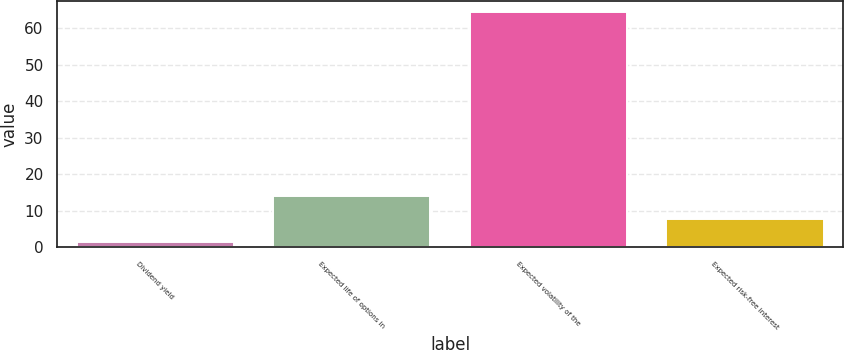<chart> <loc_0><loc_0><loc_500><loc_500><bar_chart><fcel>Dividend yield<fcel>Expected life of options in<fcel>Expected volatility of the<fcel>Expected risk-free interest<nl><fcel>1.35<fcel>13.93<fcel>64.3<fcel>7.64<nl></chart> 